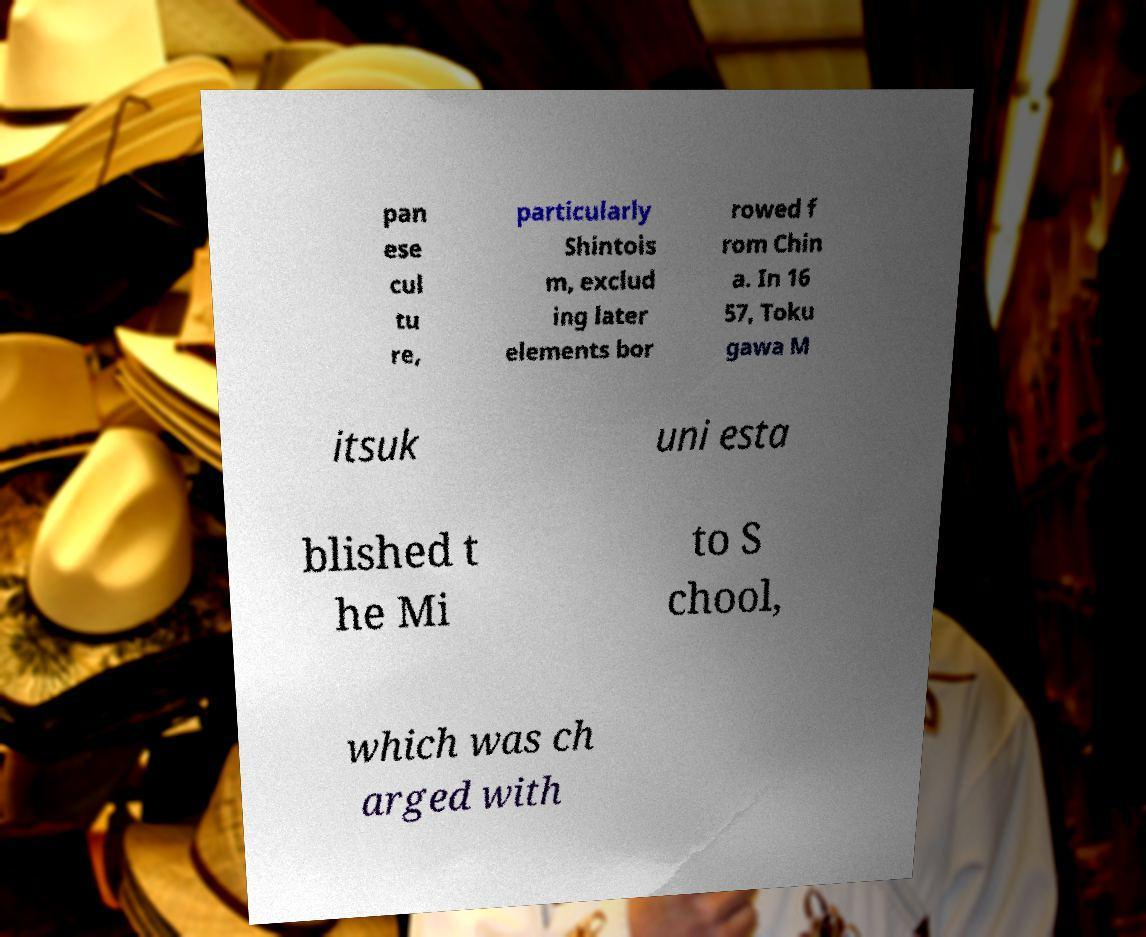Please read and relay the text visible in this image. What does it say? pan ese cul tu re, particularly Shintois m, exclud ing later elements bor rowed f rom Chin a. In 16 57, Toku gawa M itsuk uni esta blished t he Mi to S chool, which was ch arged with 